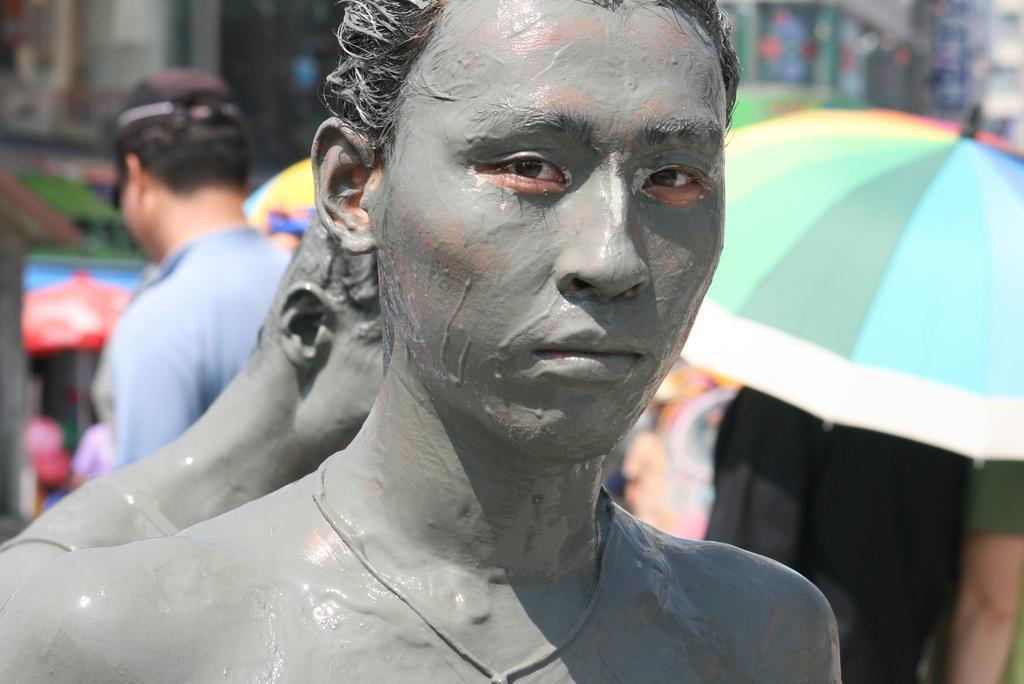Please provide a concise description of this image. In this picture there are two persons were standing near to the umbrellas. At the top I can see the blur image. 